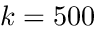<formula> <loc_0><loc_0><loc_500><loc_500>k = 5 0 0</formula> 